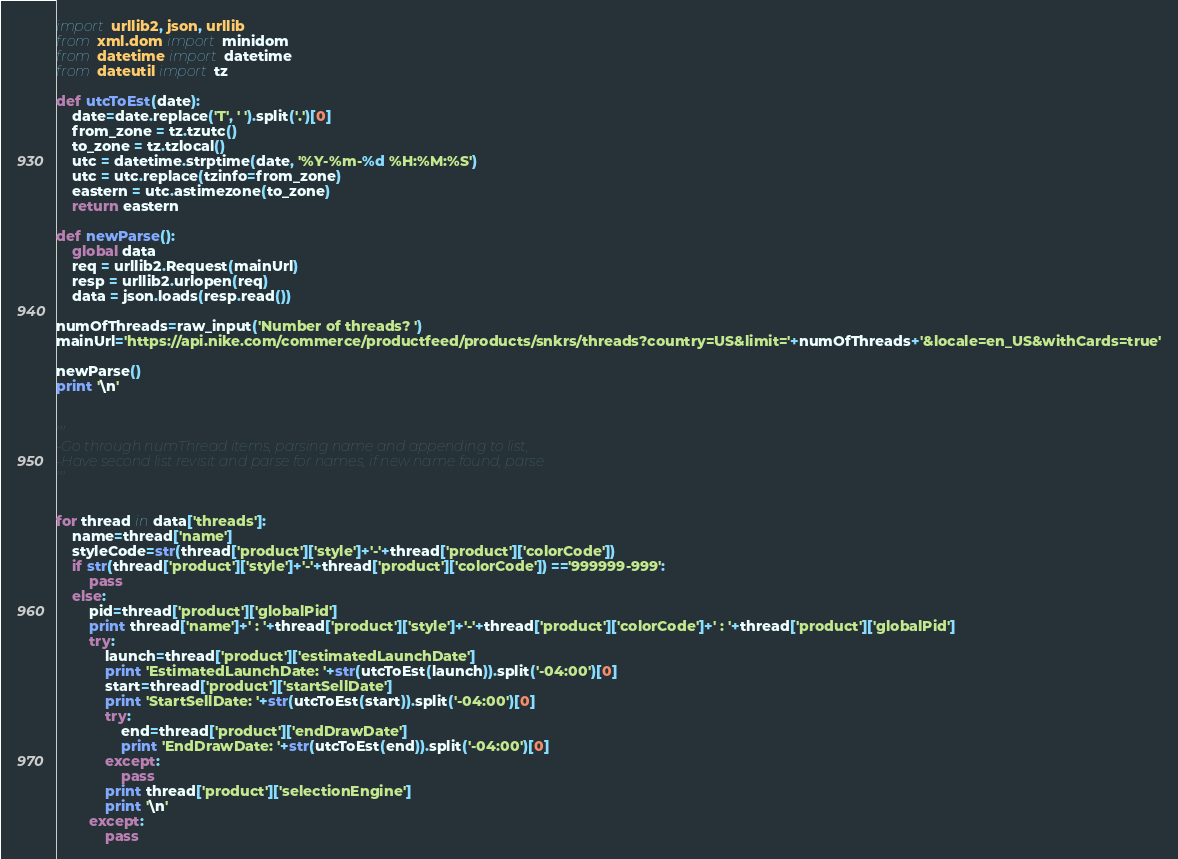Convert code to text. <code><loc_0><loc_0><loc_500><loc_500><_Python_>import urllib2, json, urllib
from xml.dom import minidom
from datetime import datetime
from dateutil import tz

def utcToEst(date):
	date=date.replace('T', ' ').split('.')[0]
	from_zone = tz.tzutc()
	to_zone = tz.tzlocal()
	utc = datetime.strptime(date, '%Y-%m-%d %H:%M:%S')
	utc = utc.replace(tzinfo=from_zone)
	eastern = utc.astimezone(to_zone)
	return eastern

def newParse():
	global data
	req = urllib2.Request(mainUrl)
	resp = urllib2.urlopen(req)
	data = json.loads(resp.read())

numOfThreads=raw_input('Number of threads? ')
mainUrl='https://api.nike.com/commerce/productfeed/products/snkrs/threads?country=US&limit='+numOfThreads+'&locale=en_US&withCards=true'

newParse()
print '\n'


'''
-Go through numThread items, parsing name and appending to list,
-Have second list revisit and parse for names, if new name found, parse
'''


for thread in data['threads']:
	name=thread['name']
	styleCode=str(thread['product']['style']+'-'+thread['product']['colorCode'])
	if str(thread['product']['style']+'-'+thread['product']['colorCode']) =='999999-999':
		pass
	else:
		pid=thread['product']['globalPid']
		print thread['name']+' : '+thread['product']['style']+'-'+thread['product']['colorCode']+' : '+thread['product']['globalPid']
		try:
			launch=thread['product']['estimatedLaunchDate']
			print 'EstimatedLaunchDate: '+str(utcToEst(launch)).split('-04:00')[0]
			start=thread['product']['startSellDate']
			print 'StartSellDate: '+str(utcToEst(start)).split('-04:00')[0]
			try:
				end=thread['product']['endDrawDate']
				print 'EndDrawDate: '+str(utcToEst(end)).split('-04:00')[0]
			except:
				pass
			print thread['product']['selectionEngine']
			print '\n'
		except:
			pass
</code> 